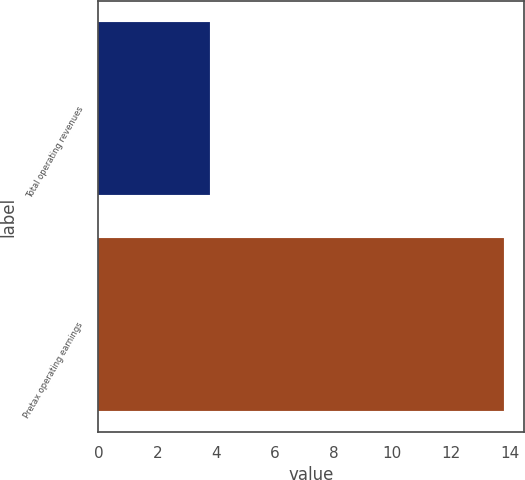<chart> <loc_0><loc_0><loc_500><loc_500><bar_chart><fcel>Total operating revenues<fcel>Pretax operating earnings<nl><fcel>3.8<fcel>13.8<nl></chart> 